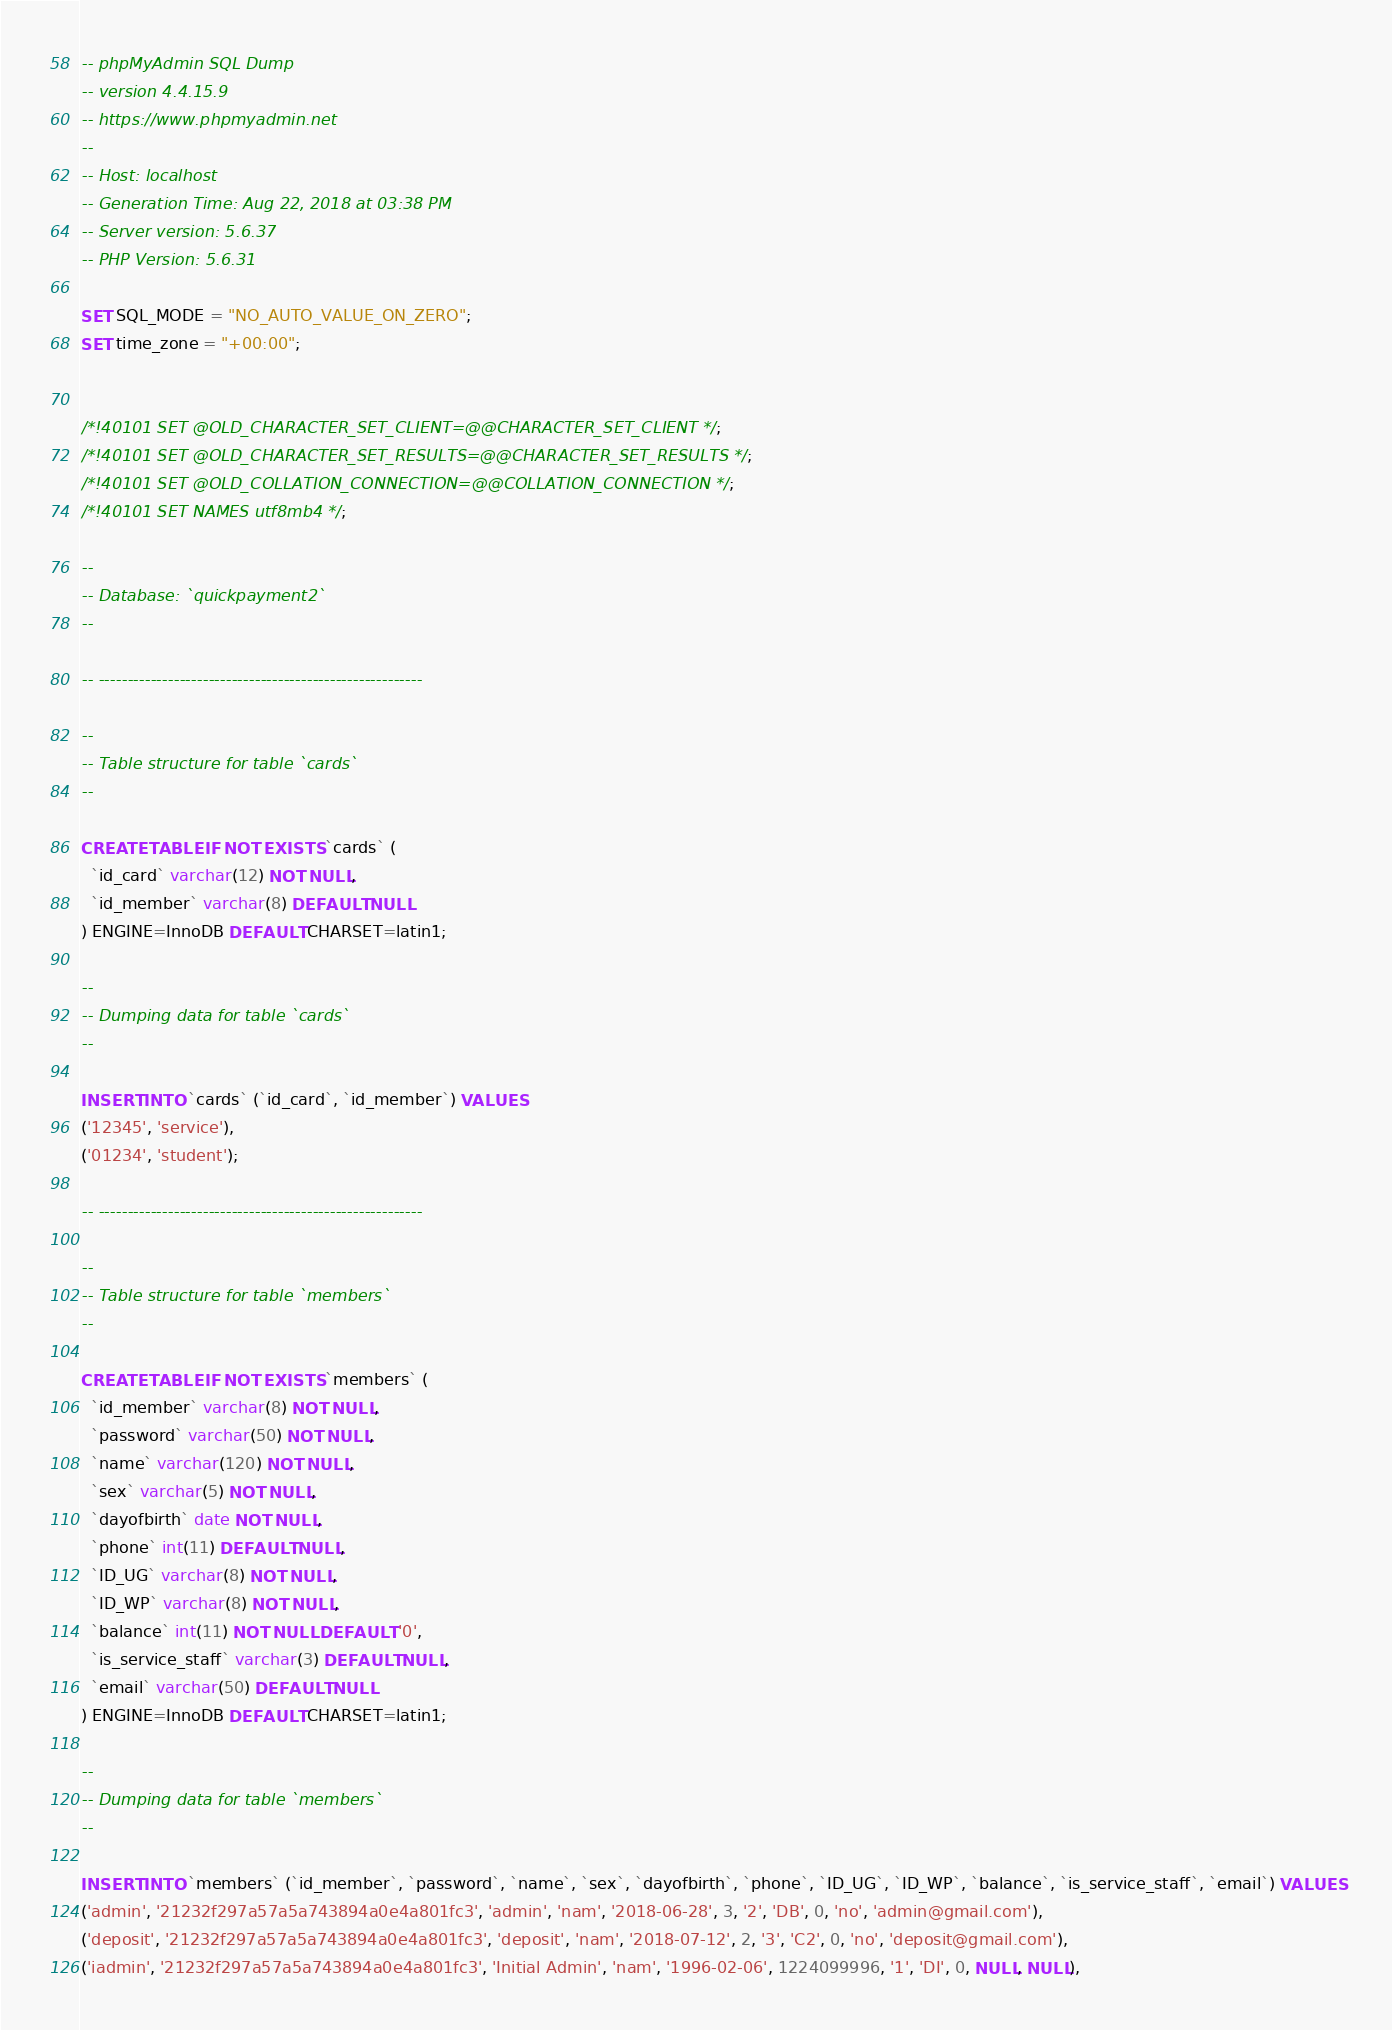Convert code to text. <code><loc_0><loc_0><loc_500><loc_500><_SQL_>-- phpMyAdmin SQL Dump
-- version 4.4.15.9
-- https://www.phpmyadmin.net
--
-- Host: localhost
-- Generation Time: Aug 22, 2018 at 03:38 PM
-- Server version: 5.6.37
-- PHP Version: 5.6.31

SET SQL_MODE = "NO_AUTO_VALUE_ON_ZERO";
SET time_zone = "+00:00";


/*!40101 SET @OLD_CHARACTER_SET_CLIENT=@@CHARACTER_SET_CLIENT */;
/*!40101 SET @OLD_CHARACTER_SET_RESULTS=@@CHARACTER_SET_RESULTS */;
/*!40101 SET @OLD_COLLATION_CONNECTION=@@COLLATION_CONNECTION */;
/*!40101 SET NAMES utf8mb4 */;

--
-- Database: `quickpayment2`
--

-- --------------------------------------------------------

--
-- Table structure for table `cards`
--

CREATE TABLE IF NOT EXISTS `cards` (
  `id_card` varchar(12) NOT NULL,
  `id_member` varchar(8) DEFAULT NULL
) ENGINE=InnoDB DEFAULT CHARSET=latin1;

--
-- Dumping data for table `cards`
--

INSERT INTO `cards` (`id_card`, `id_member`) VALUES
('12345', 'service'),
('01234', 'student');

-- --------------------------------------------------------

--
-- Table structure for table `members`
--

CREATE TABLE IF NOT EXISTS `members` (
  `id_member` varchar(8) NOT NULL,
  `password` varchar(50) NOT NULL,
  `name` varchar(120) NOT NULL,
  `sex` varchar(5) NOT NULL,
  `dayofbirth` date NOT NULL,
  `phone` int(11) DEFAULT NULL,
  `ID_UG` varchar(8) NOT NULL,
  `ID_WP` varchar(8) NOT NULL,
  `balance` int(11) NOT NULL DEFAULT '0',
  `is_service_staff` varchar(3) DEFAULT NULL,
  `email` varchar(50) DEFAULT NULL
) ENGINE=InnoDB DEFAULT CHARSET=latin1;

--
-- Dumping data for table `members`
--

INSERT INTO `members` (`id_member`, `password`, `name`, `sex`, `dayofbirth`, `phone`, `ID_UG`, `ID_WP`, `balance`, `is_service_staff`, `email`) VALUES
('admin', '21232f297a57a5a743894a0e4a801fc3', 'admin', 'nam', '2018-06-28', 3, '2', 'DB', 0, 'no', 'admin@gmail.com'),
('deposit', '21232f297a57a5a743894a0e4a801fc3', 'deposit', 'nam', '2018-07-12', 2, '3', 'C2', 0, 'no', 'deposit@gmail.com'),
('iadmin', '21232f297a57a5a743894a0e4a801fc3', 'Initial Admin', 'nam', '1996-02-06', 1224099996, '1', 'DI', 0, NULL, NULL),</code> 